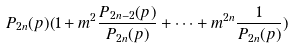Convert formula to latex. <formula><loc_0><loc_0><loc_500><loc_500>P _ { 2 n } ( p ) ( 1 + m ^ { 2 } \frac { P _ { 2 n - 2 } ( p ) } { P _ { 2 n } ( p ) } + \dots + m ^ { 2 n } \frac { 1 } { P _ { 2 n } ( p ) } )</formula> 